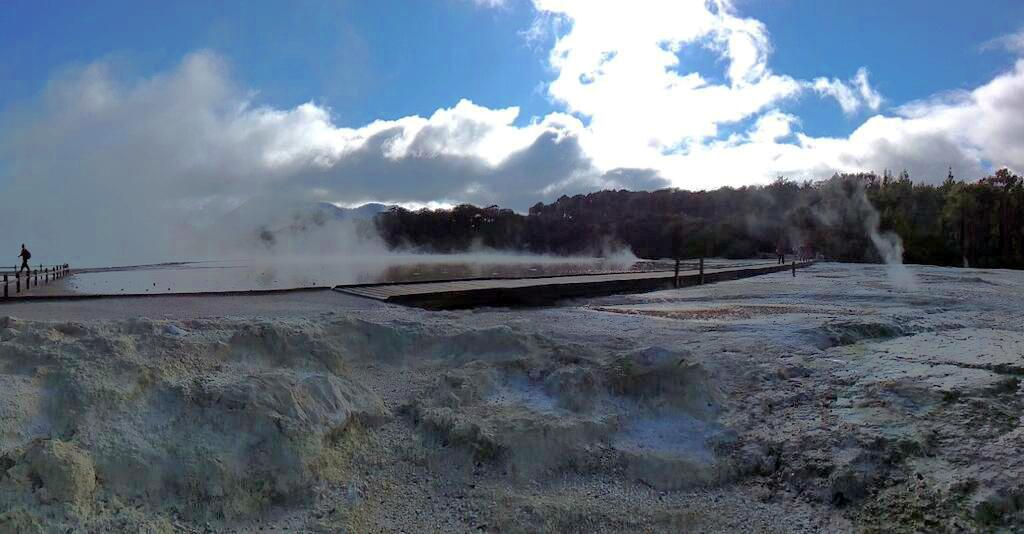What is the main subject in the center of the image? There is water in the center of the image. What is happening on the left side of the image? There is a person walking on the left side of the image. What type of vegetation is on the right side of the image? There are trees on the right side of the image. How many persons are visible in the image? There are persons visible in the image. What is the condition of the sky in the image? The sky is cloudy in the image. What type of glass is being used to commit a crime in the image? There is no glass or crime present in the image; it features water, a person walking, trees, and a cloudy sky. 